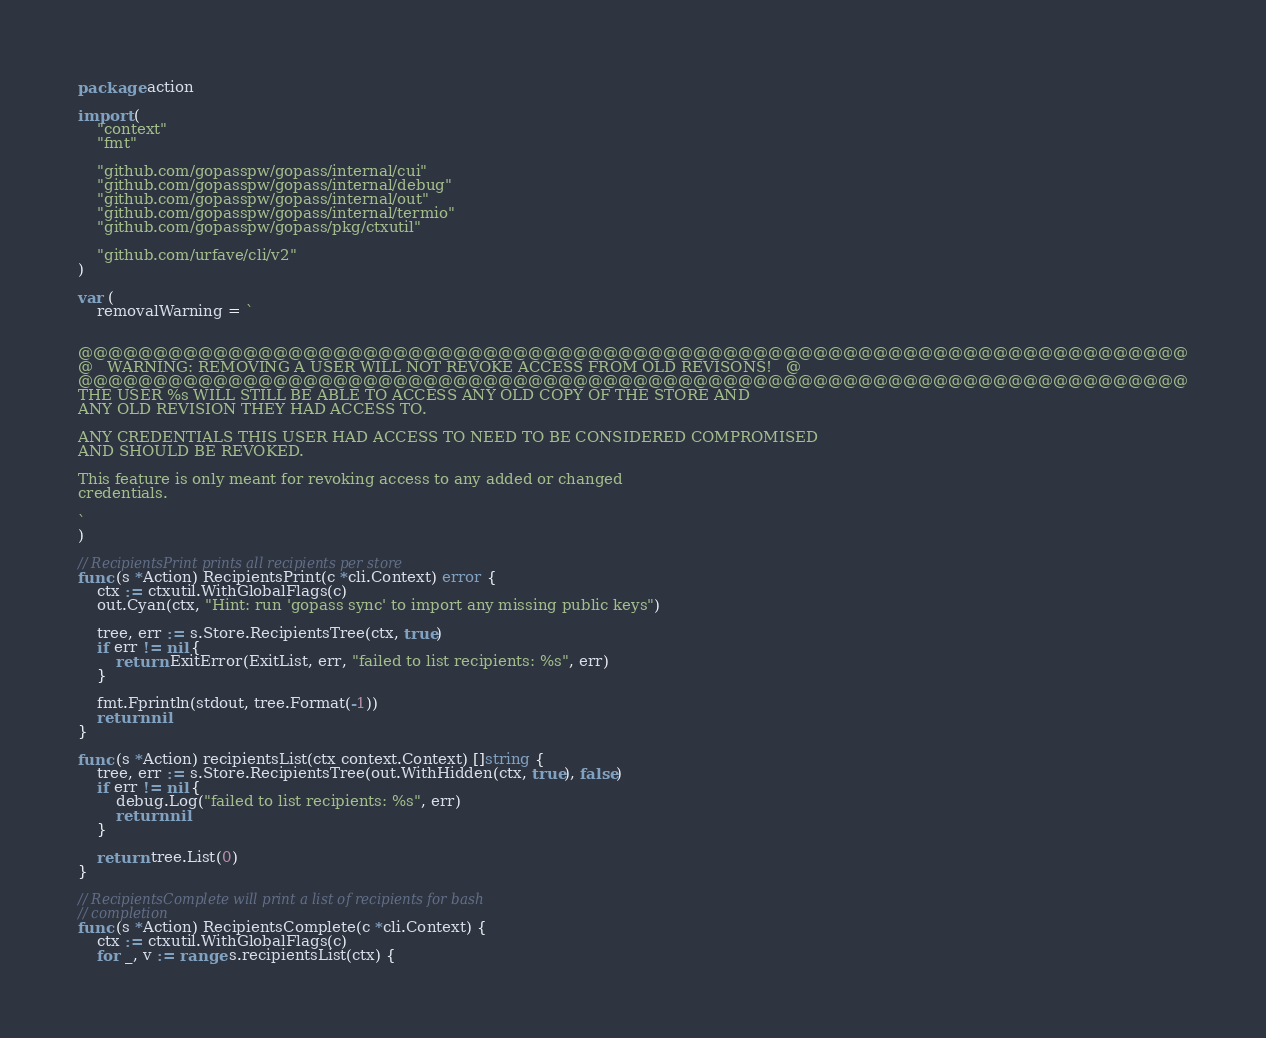<code> <loc_0><loc_0><loc_500><loc_500><_Go_>package action

import (
	"context"
	"fmt"

	"github.com/gopasspw/gopass/internal/cui"
	"github.com/gopasspw/gopass/internal/debug"
	"github.com/gopasspw/gopass/internal/out"
	"github.com/gopasspw/gopass/internal/termio"
	"github.com/gopasspw/gopass/pkg/ctxutil"

	"github.com/urfave/cli/v2"
)

var (
	removalWarning = `


@@@@@@@@@@@@@@@@@@@@@@@@@@@@@@@@@@@@@@@@@@@@@@@@@@@@@@@@@@@@@@@@@@@@@@@@@@
@   WARNING: REMOVING A USER WILL NOT REVOKE ACCESS FROM OLD REVISONS!   @
@@@@@@@@@@@@@@@@@@@@@@@@@@@@@@@@@@@@@@@@@@@@@@@@@@@@@@@@@@@@@@@@@@@@@@@@@@
THE USER %s WILL STILL BE ABLE TO ACCESS ANY OLD COPY OF THE STORE AND
ANY OLD REVISION THEY HAD ACCESS TO.

ANY CREDENTIALS THIS USER HAD ACCESS TO NEED TO BE CONSIDERED COMPROMISED
AND SHOULD BE REVOKED.

This feature is only meant for revoking access to any added or changed
credentials.

`
)

// RecipientsPrint prints all recipients per store
func (s *Action) RecipientsPrint(c *cli.Context) error {
	ctx := ctxutil.WithGlobalFlags(c)
	out.Cyan(ctx, "Hint: run 'gopass sync' to import any missing public keys")

	tree, err := s.Store.RecipientsTree(ctx, true)
	if err != nil {
		return ExitError(ExitList, err, "failed to list recipients: %s", err)
	}

	fmt.Fprintln(stdout, tree.Format(-1))
	return nil
}

func (s *Action) recipientsList(ctx context.Context) []string {
	tree, err := s.Store.RecipientsTree(out.WithHidden(ctx, true), false)
	if err != nil {
		debug.Log("failed to list recipients: %s", err)
		return nil
	}

	return tree.List(0)
}

// RecipientsComplete will print a list of recipients for bash
// completion
func (s *Action) RecipientsComplete(c *cli.Context) {
	ctx := ctxutil.WithGlobalFlags(c)
	for _, v := range s.recipientsList(ctx) {</code> 